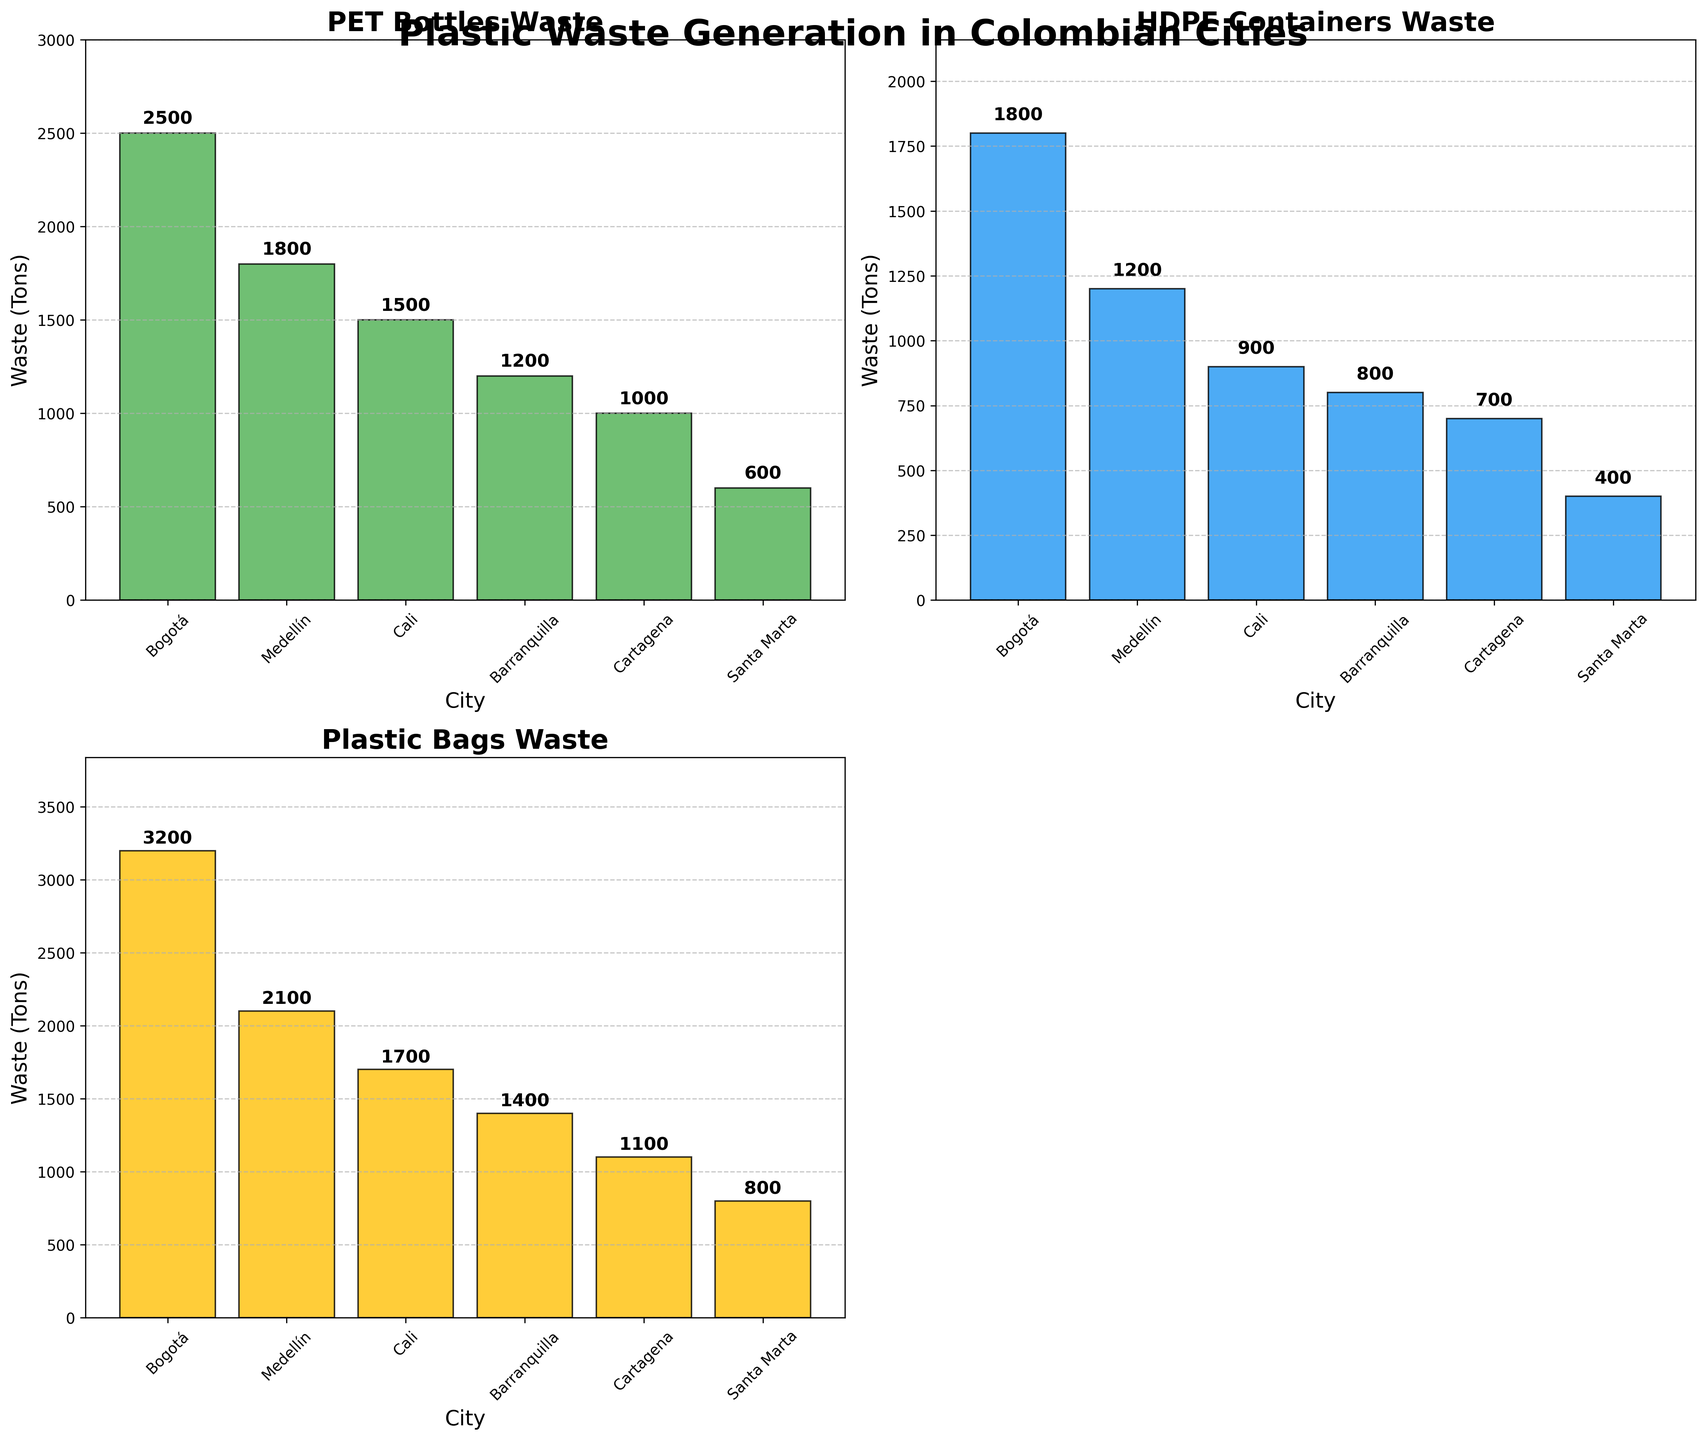Which city has the highest PET Bottles waste generation? Bogotá has the highest PET Bottles waste generation. This can be seen by looking at the height of the bars in the PET Bottles subplot, where Bogotá’s bar is the tallest.
Answer: Bogotá Which type of plastic waste is most generated in Medellín? In the Medellín subplot across all types, Plastic Bags have the highest generation, indicated by the tallest bar in the Medellín section under Plastic Bags.
Answer: Plastic Bags How much HDPE Containers waste does Cali generate? In the HDPE Containers subplot, look at the height of the bar corresponding to Cali, which indicates 900 tons.
Answer: 900 tons Compare the PET Bottles waste generation between Cartagena and Santa Marta. Which city produces more and by how much? Cartagena generates 1000 tons of PET Bottles waste, while Santa Marta generates 600 tons. The difference is 1000 - 600 = 400 tons.
Answer: Cartagena by 400 tons What is the total plastic waste generation (sum of all types) in Barranquilla? Barranquilla generates 1200 tons of PET Bottles, 800 tons of HDPE Containers, and 1400 tons of Plastic Bags. Summing these values, 1200 + 800 + 1400 = 3400 tons.
Answer: 3400 tons What is the average waste generation of Plastic Bags across all cities? The waste generation of Plastic Bags are 3200 (Bogotá), 2100 (Medellín), 1700 (Cali), 1400 (Barranquilla), 1100 (Cartagena), and 800 (Santa Marta). Sum these and divide by the number of cities: (3200 + 2100 + 1700 + 1400 + 1100 + 800) / 6 = 10300 / 6 ≈ 1716.67 tons.
Answer: 1716.67 tons Which city has the lowest total waste generation of all types combined? Santa Marta has the lowest total waste, with 600 tons (PET Bottles) + 400 tons (HDPE Containers) + 800 tons (Plastic Bags) = 1800 tons in total.
Answer: Santa Marta Among the provided cities, how much more Plastic Bags waste does Bogotá generate compared to Cali? Bogotá generates 3200 tons and Cali generates 1700 tons of Plastic Bags waste. Thus, Bogotá generates 3200 - 1700 = 1500 tons more than Cali.
Answer: 1500 tons What are the colors used for indicating different types of plastic waste in the figure? The subplots have distinct colors: PET Bottles (green), HDPE Containers (blue), Plastic Bags (yellow).
Answer: Green, Blue, Yellow By comparing PET Bottles and HDPE Containers, in which type does Medellín generate more waste and by how much? Medellín generates 1800 tons of PET Bottles and 1200 tons of HDPE Containers. Hence, Medellín generates 1800 - 1200 = 600 tons more PET Bottles waste.
Answer: PET Bottles by 600 tons 